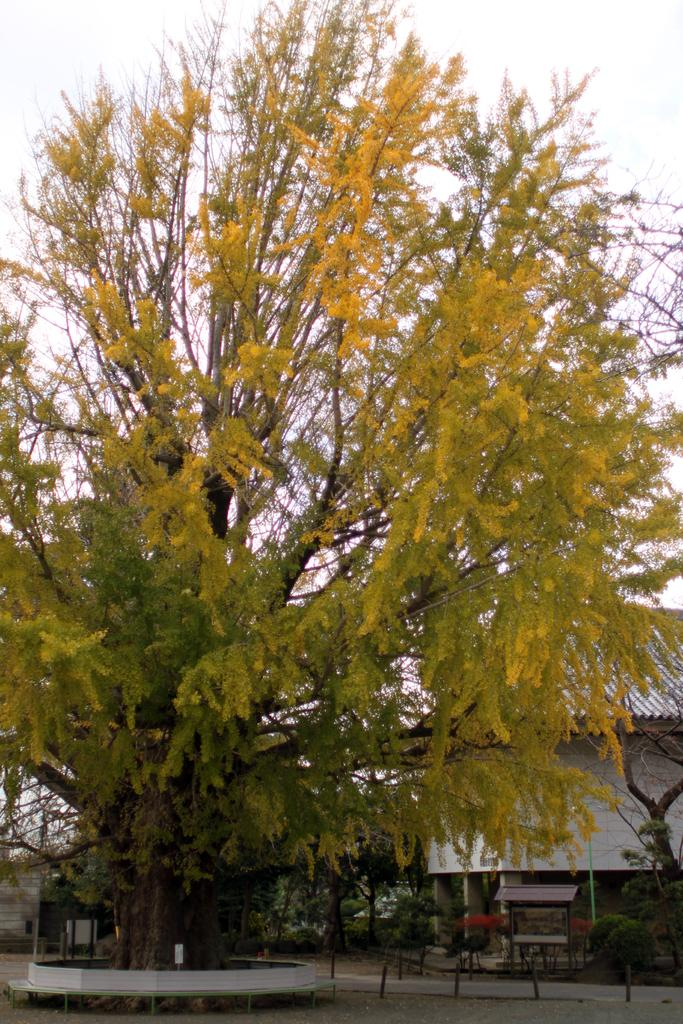What type of natural element is present in the image? There is a tree in the image. What can be seen in the background of the image? There is a roof top and plants visible in the background of the image. What part of the natural environment is visible in the image? The sky is visible in the background of the image. What is the price of the tree in the image? There is no price associated with the tree in the image, as it is a natural element and not a product for sale. 